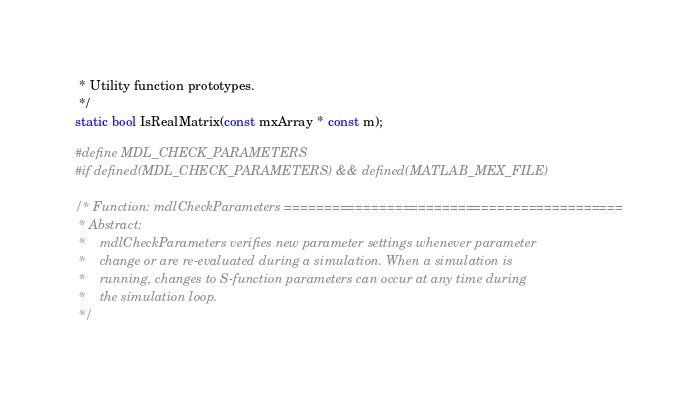<code> <loc_0><loc_0><loc_500><loc_500><_C_> * Utility function prototypes.
 */
static bool IsRealMatrix(const mxArray * const m);

#define MDL_CHECK_PARAMETERS
#if defined(MDL_CHECK_PARAMETERS) && defined(MATLAB_MEX_FILE)

/* Function: mdlCheckParameters ===========================================
 * Abstract:
 *    mdlCheckParameters verifies new parameter settings whenever parameter
 *    change or are re-evaluated during a simulation. When a simulation is
 *    running, changes to S-function parameters can occur at any time during
 *    the simulation loop.
 */</code> 